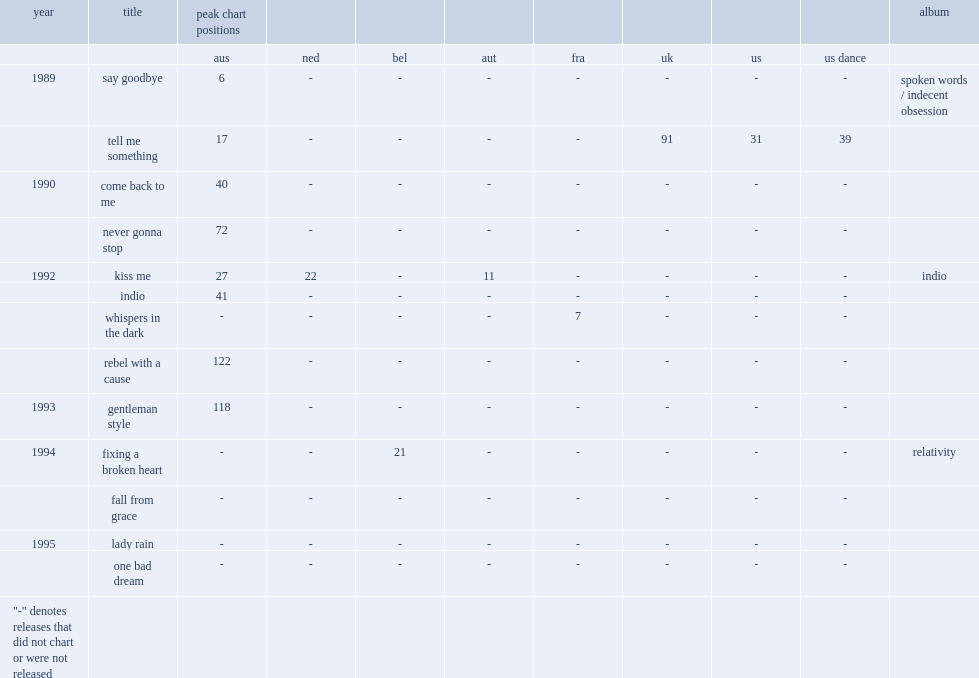When did the single kiss me release? 1992.0. 